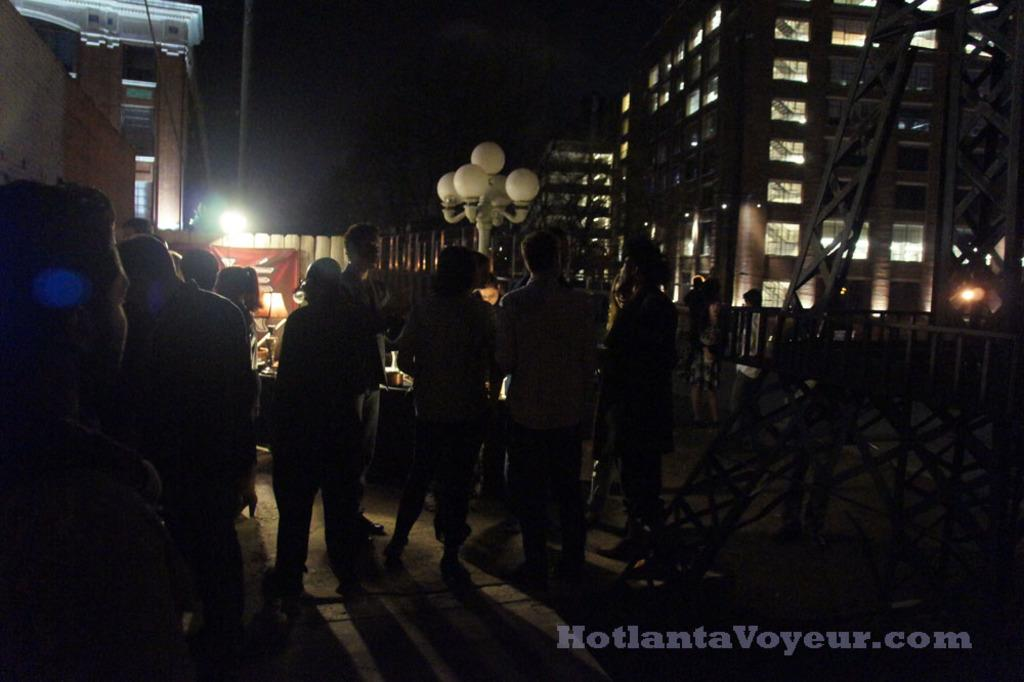What is located in the foreground of the image? In the foreground of the image, there is a crowd, a table, poles, and metal rods. What can be seen on the road in the foreground of the image? There is text on the road in the foreground of the image. What is visible in the background of the image? In the background of the image, there are buildings and the sky. Can you describe the lighting conditions in the image? The image may have been taken during the night, as there is no mention of sunlight or daylight. What type of design is featured on the debt in the image? There is no mention of debt in the image, so it is not possible to answer this question. How does the crowd blow in the image? The crowd does not blow in the image; it is a stationary group of people. 